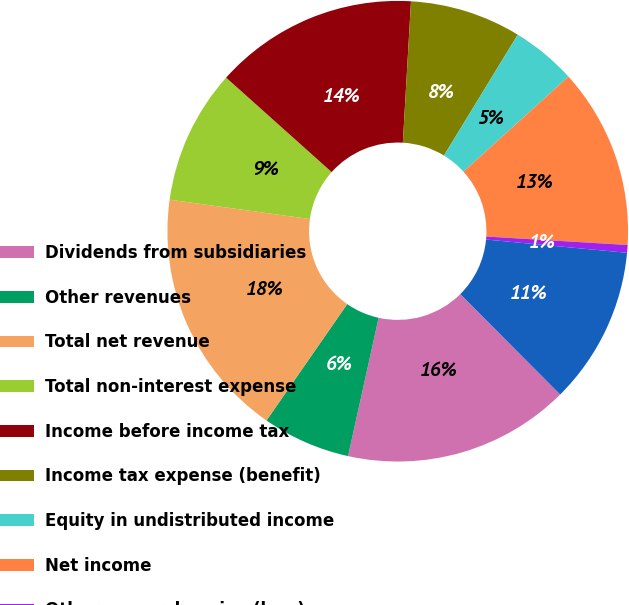<chart> <loc_0><loc_0><loc_500><loc_500><pie_chart><fcel>Dividends from subsidiaries<fcel>Other revenues<fcel>Total net revenue<fcel>Total non-interest expense<fcel>Income before income tax<fcel>Income tax expense (benefit)<fcel>Equity in undistributed income<fcel>Net income<fcel>Other comprehensive (loss)<fcel>Comprehensive income<nl><fcel>15.92%<fcel>6.19%<fcel>17.54%<fcel>9.43%<fcel>14.3%<fcel>7.81%<fcel>4.56%<fcel>12.67%<fcel>0.54%<fcel>11.05%<nl></chart> 